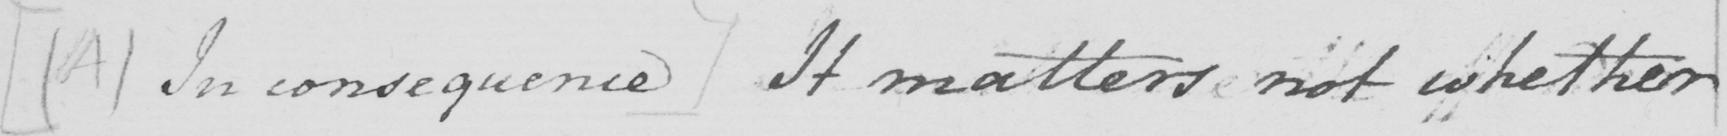Can you read and transcribe this handwriting? [  ( A )  In consequence ]  It matters not whether 